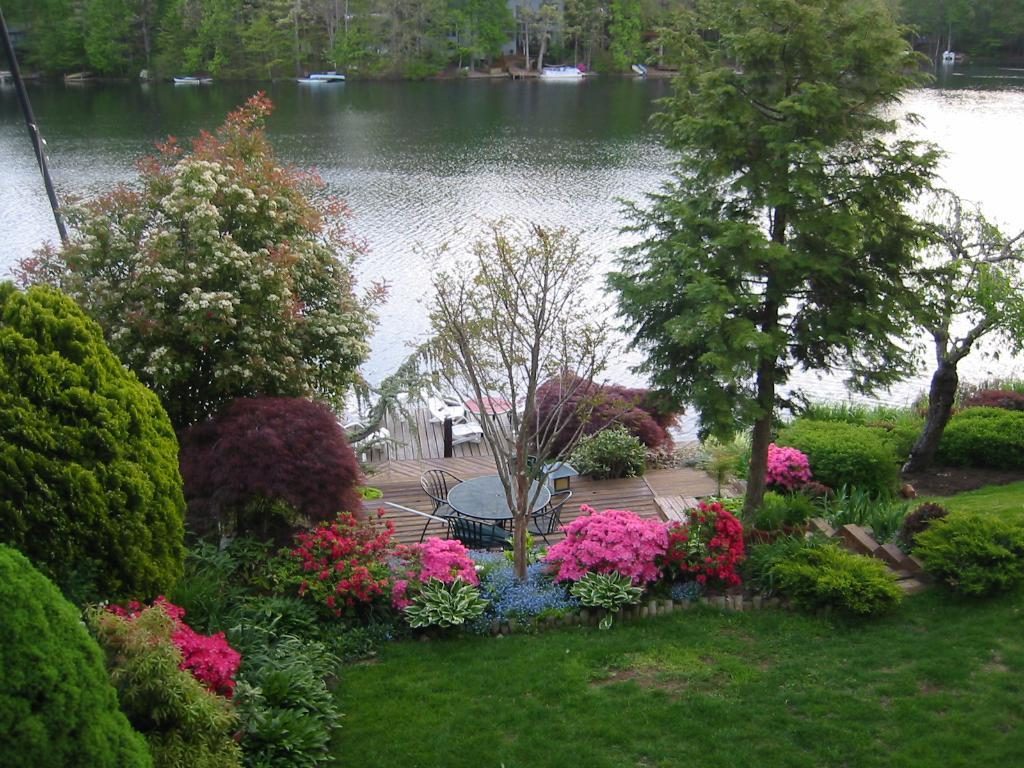What type of furniture is present in the image? There is a table and chairs in the image. What type of surface is under the table and chairs? There is wooden flooring in the image. What type of natural environment is visible in the image? Grass, trees, and a river are present in the image. What type of vegetation can be seen in the image? Plants and trees are visible in the image. What type of watercraft can be seen in the image? Boats are visible in the image. How many dogs are swimming in the ocean in the image? There is no ocean or dogs present in the image. What type of bag is hanging on the tree in the image? There is no bag present in the image. 